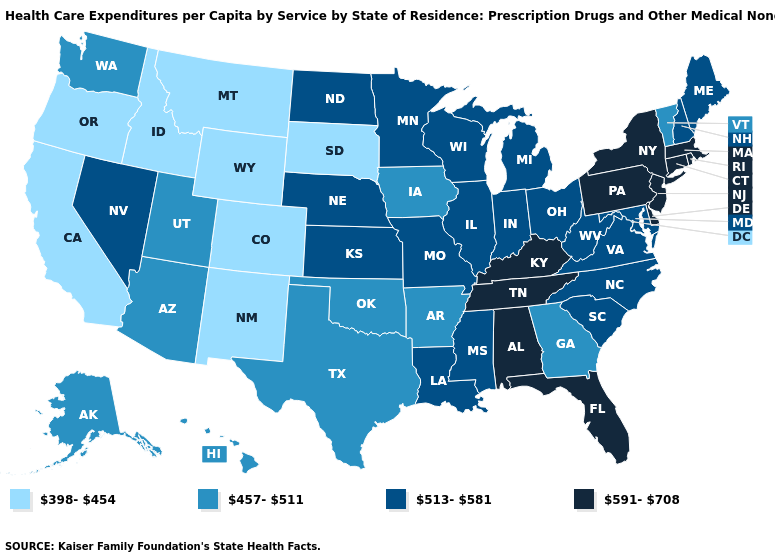What is the lowest value in states that border New York?
Quick response, please. 457-511. Name the states that have a value in the range 457-511?
Be succinct. Alaska, Arizona, Arkansas, Georgia, Hawaii, Iowa, Oklahoma, Texas, Utah, Vermont, Washington. Does the first symbol in the legend represent the smallest category?
Answer briefly. Yes. Name the states that have a value in the range 591-708?
Be succinct. Alabama, Connecticut, Delaware, Florida, Kentucky, Massachusetts, New Jersey, New York, Pennsylvania, Rhode Island, Tennessee. Among the states that border Ohio , which have the lowest value?
Give a very brief answer. Indiana, Michigan, West Virginia. Among the states that border Michigan , which have the highest value?
Short answer required. Indiana, Ohio, Wisconsin. What is the lowest value in the USA?
Answer briefly. 398-454. What is the highest value in the USA?
Quick response, please. 591-708. Does South Dakota have the lowest value in the USA?
Concise answer only. Yes. What is the value of Maine?
Write a very short answer. 513-581. What is the highest value in the USA?
Keep it brief. 591-708. What is the value of Colorado?
Short answer required. 398-454. What is the value of Wisconsin?
Answer briefly. 513-581. Name the states that have a value in the range 457-511?
Answer briefly. Alaska, Arizona, Arkansas, Georgia, Hawaii, Iowa, Oklahoma, Texas, Utah, Vermont, Washington. Does Illinois have the lowest value in the USA?
Be succinct. No. 